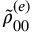<formula> <loc_0><loc_0><loc_500><loc_500>\tilde { \rho } _ { 0 0 } ^ { ( e ) }</formula> 